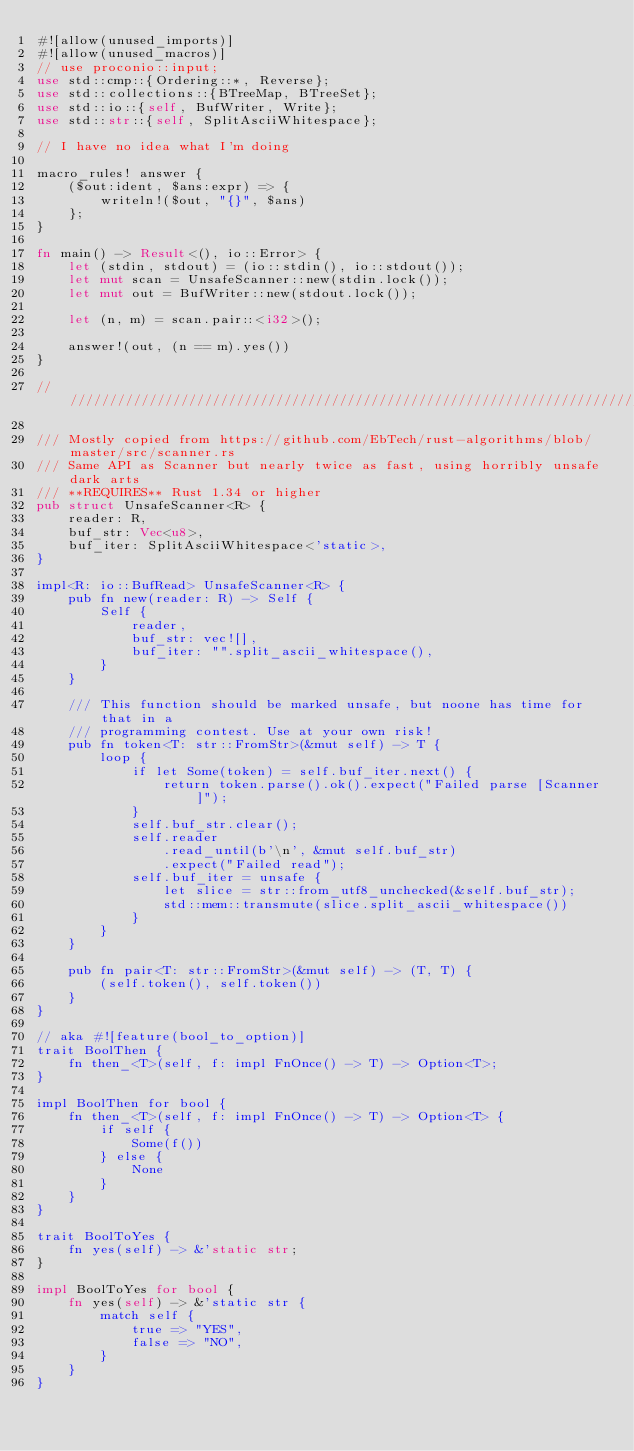Convert code to text. <code><loc_0><loc_0><loc_500><loc_500><_Rust_>#![allow(unused_imports)]
#![allow(unused_macros)]
// use proconio::input;
use std::cmp::{Ordering::*, Reverse};
use std::collections::{BTreeMap, BTreeSet};
use std::io::{self, BufWriter, Write};
use std::str::{self, SplitAsciiWhitespace};

// I have no idea what I'm doing

macro_rules! answer {
    ($out:ident, $ans:expr) => {
        writeln!($out, "{}", $ans)
    };
}

fn main() -> Result<(), io::Error> {
    let (stdin, stdout) = (io::stdin(), io::stdout());
    let mut scan = UnsafeScanner::new(stdin.lock());
    let mut out = BufWriter::new(stdout.lock());

    let (n, m) = scan.pair::<i32>();

    answer!(out, (n == m).yes())
}

///////////////////////////////////////////////////////////////////////////////////////////////////

/// Mostly copied from https://github.com/EbTech/rust-algorithms/blob/master/src/scanner.rs
/// Same API as Scanner but nearly twice as fast, using horribly unsafe dark arts
/// **REQUIRES** Rust 1.34 or higher
pub struct UnsafeScanner<R> {
    reader: R,
    buf_str: Vec<u8>,
    buf_iter: SplitAsciiWhitespace<'static>,
}

impl<R: io::BufRead> UnsafeScanner<R> {
    pub fn new(reader: R) -> Self {
        Self {
            reader,
            buf_str: vec![],
            buf_iter: "".split_ascii_whitespace(),
        }
    }

    /// This function should be marked unsafe, but noone has time for that in a
    /// programming contest. Use at your own risk!
    pub fn token<T: str::FromStr>(&mut self) -> T {
        loop {
            if let Some(token) = self.buf_iter.next() {
                return token.parse().ok().expect("Failed parse [Scanner]");
            }
            self.buf_str.clear();
            self.reader
                .read_until(b'\n', &mut self.buf_str)
                .expect("Failed read");
            self.buf_iter = unsafe {
                let slice = str::from_utf8_unchecked(&self.buf_str);
                std::mem::transmute(slice.split_ascii_whitespace())
            }
        }
    }

    pub fn pair<T: str::FromStr>(&mut self) -> (T, T) {
        (self.token(), self.token())
    }
}

// aka #![feature(bool_to_option)]
trait BoolThen {
    fn then_<T>(self, f: impl FnOnce() -> T) -> Option<T>;
}

impl BoolThen for bool {
    fn then_<T>(self, f: impl FnOnce() -> T) -> Option<T> {
        if self {
            Some(f())
        } else {
            None
        }
    }
}

trait BoolToYes {
    fn yes(self) -> &'static str;
}

impl BoolToYes for bool {
    fn yes(self) -> &'static str {
        match self {
            true => "YES",
            false => "NO",
        }
    }
}
</code> 